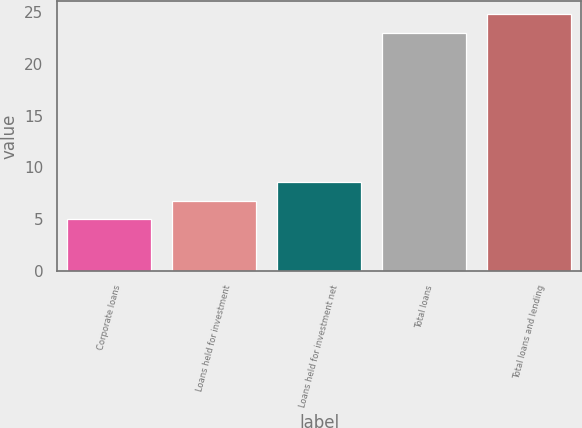<chart> <loc_0><loc_0><loc_500><loc_500><bar_chart><fcel>Corporate loans<fcel>Loans held for investment<fcel>Loans held for investment net<fcel>Total loans<fcel>Total loans and lending<nl><fcel>5<fcel>6.8<fcel>8.6<fcel>23<fcel>24.8<nl></chart> 